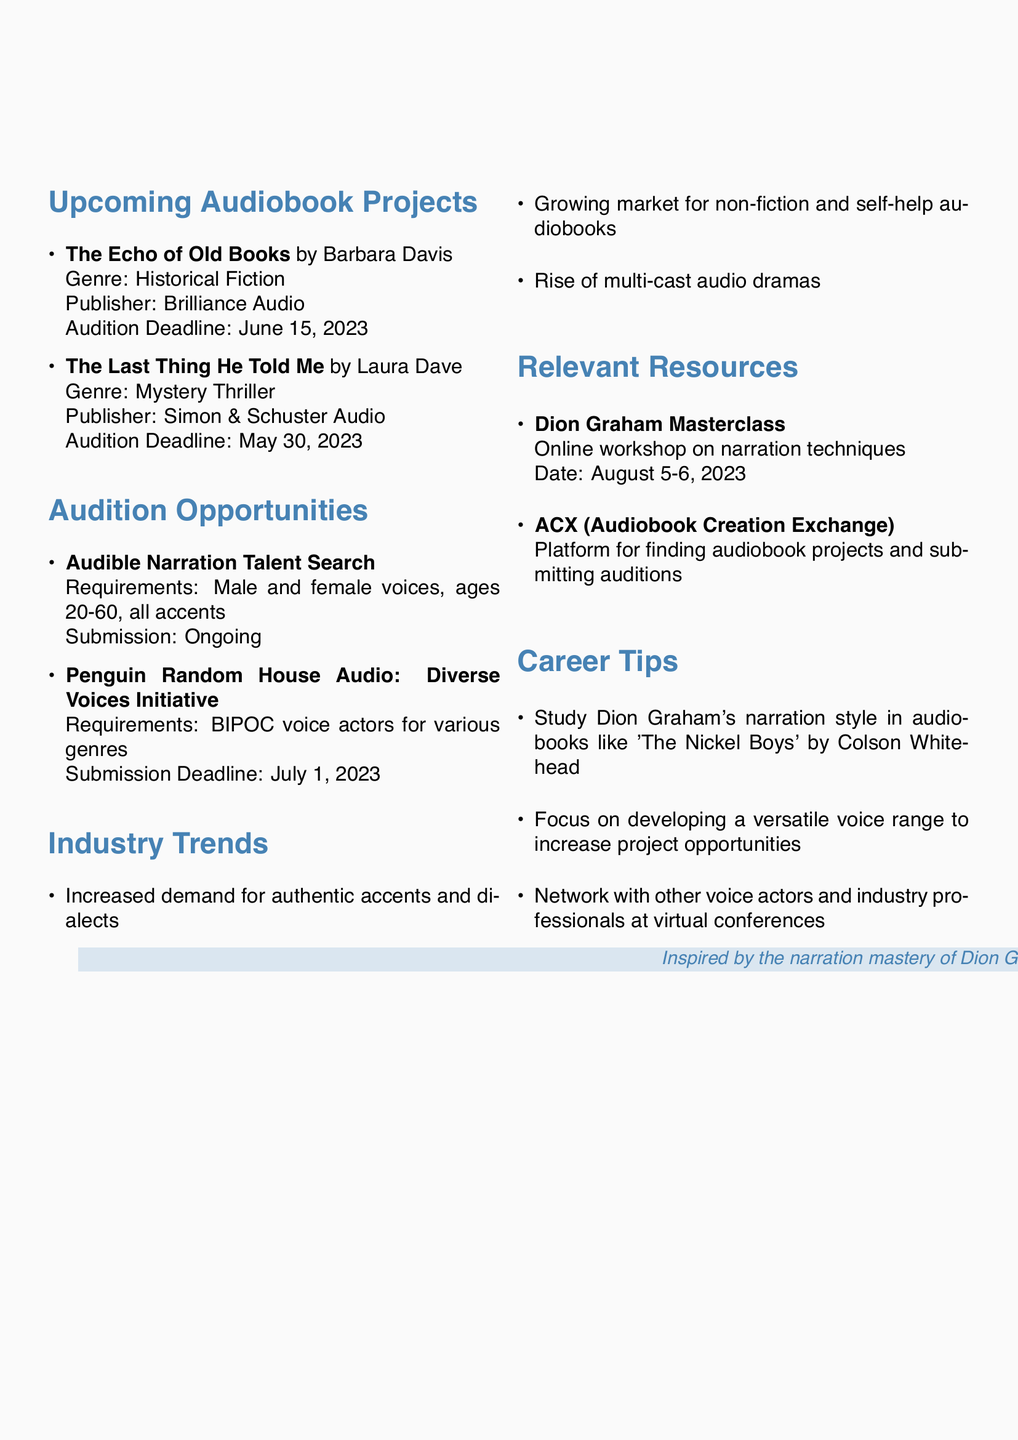What is the title of the audiobook by Barbara Davis? The document lists "The Echo of Old Books" as the title of the audiobook by Barbara Davis.
Answer: The Echo of Old Books What genre is "The Last Thing He Told Me"? The document indicates that "The Last Thing He Told Me" is categorized under Mystery Thriller.
Answer: Mystery Thriller When is the audition deadline for the "Diverse Voices Initiative"? The document states that the submission deadline for the "Diverse Voices Initiative" is July 1, 2023.
Answer: July 1, 2023 Which company is hosting an ongoing talent search? The document mentions that Audible is hosting the ongoing talent search.
Answer: Audible What is one trend in the audiobook industry mentioned in the document? The document lists several trends, one being the increased demand for authentic accents and dialects.
Answer: Increased demand for authentic accents and dialects Who is conducting a masterclass on narration techniques? The document specifies that Dion Graham is conducting the masterclass on narration techniques.
Answer: Dion Graham When is the Dion Graham Masterclass scheduled? According to the document, the Dion Graham Masterclass is scheduled for August 5-6, 2023.
Answer: August 5-6, 2023 What is one career tip provided in the document? The document suggests studying Dion Graham’s narration style in "The Nickel Boys" as a career tip.
Answer: Study Dion Graham's narration style in 'The Nickel Boys' How many audiobooks projects are listed in the document? The document provides a list of two upcoming audiobook projects.
Answer: 2 What requirement is specified for the Audible Narration Talent Search? The document states the requirement includes male and female voices, ages 20-60, all accents.
Answer: Male and female voices, ages 20-60, all accents 